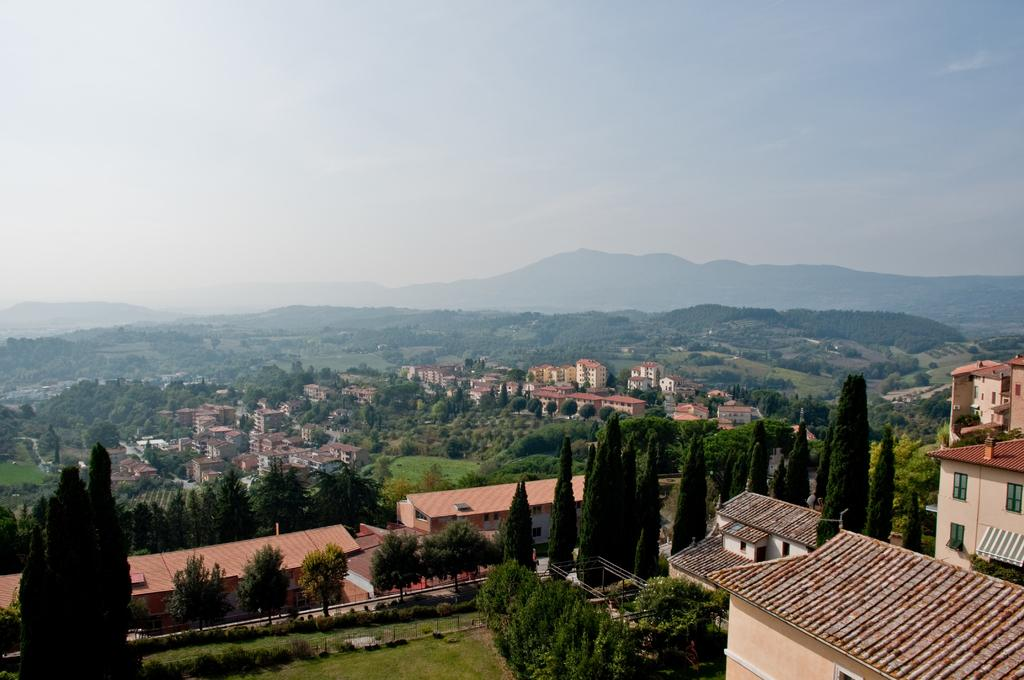What type of natural elements can be seen in the image? There are trees in the image. What type of man-made structures are present in the image? There are buildings and houses in the image. What can be seen in the distance in the image? There are mountains visible in the background of the image. How is the sky depicted in the image? The sky is clear in the background of the image. Where is the kettle located in the image? There is no kettle present in the image. What type of wind can be seen blowing through the trees in the image? There is no wind visible in the image, and the term "zephyr" is not relevant to the image. 